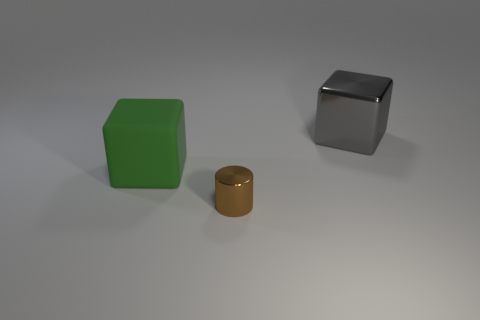Add 2 brown shiny cylinders. How many objects exist? 5 Subtract all green cubes. How many cubes are left? 1 Subtract all cylinders. How many objects are left? 2 Subtract all green cubes. Subtract all cyan cylinders. How many cubes are left? 1 Subtract all red blocks. How many red cylinders are left? 0 Subtract all gray balls. Subtract all big green things. How many objects are left? 2 Add 2 large gray objects. How many large gray objects are left? 3 Add 3 cubes. How many cubes exist? 5 Subtract 0 green cylinders. How many objects are left? 3 Subtract 2 blocks. How many blocks are left? 0 